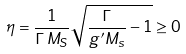Convert formula to latex. <formula><loc_0><loc_0><loc_500><loc_500>\eta = \frac { 1 } { \Gamma \, M _ { S } } \sqrt { \frac { \Gamma } { g ^ { \prime } M _ { s } } - 1 } \geq 0</formula> 